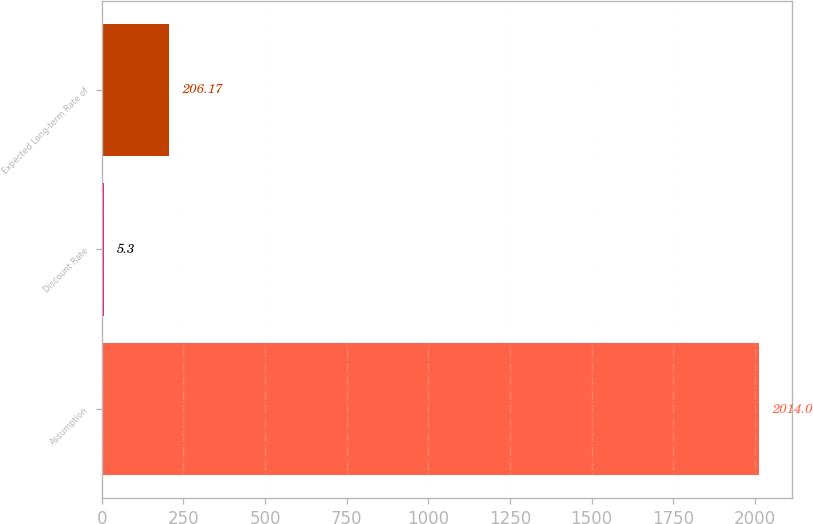Convert chart to OTSL. <chart><loc_0><loc_0><loc_500><loc_500><bar_chart><fcel>Assumption<fcel>Discount Rate<fcel>Expected Long-term Rate of<nl><fcel>2014<fcel>5.3<fcel>206.17<nl></chart> 